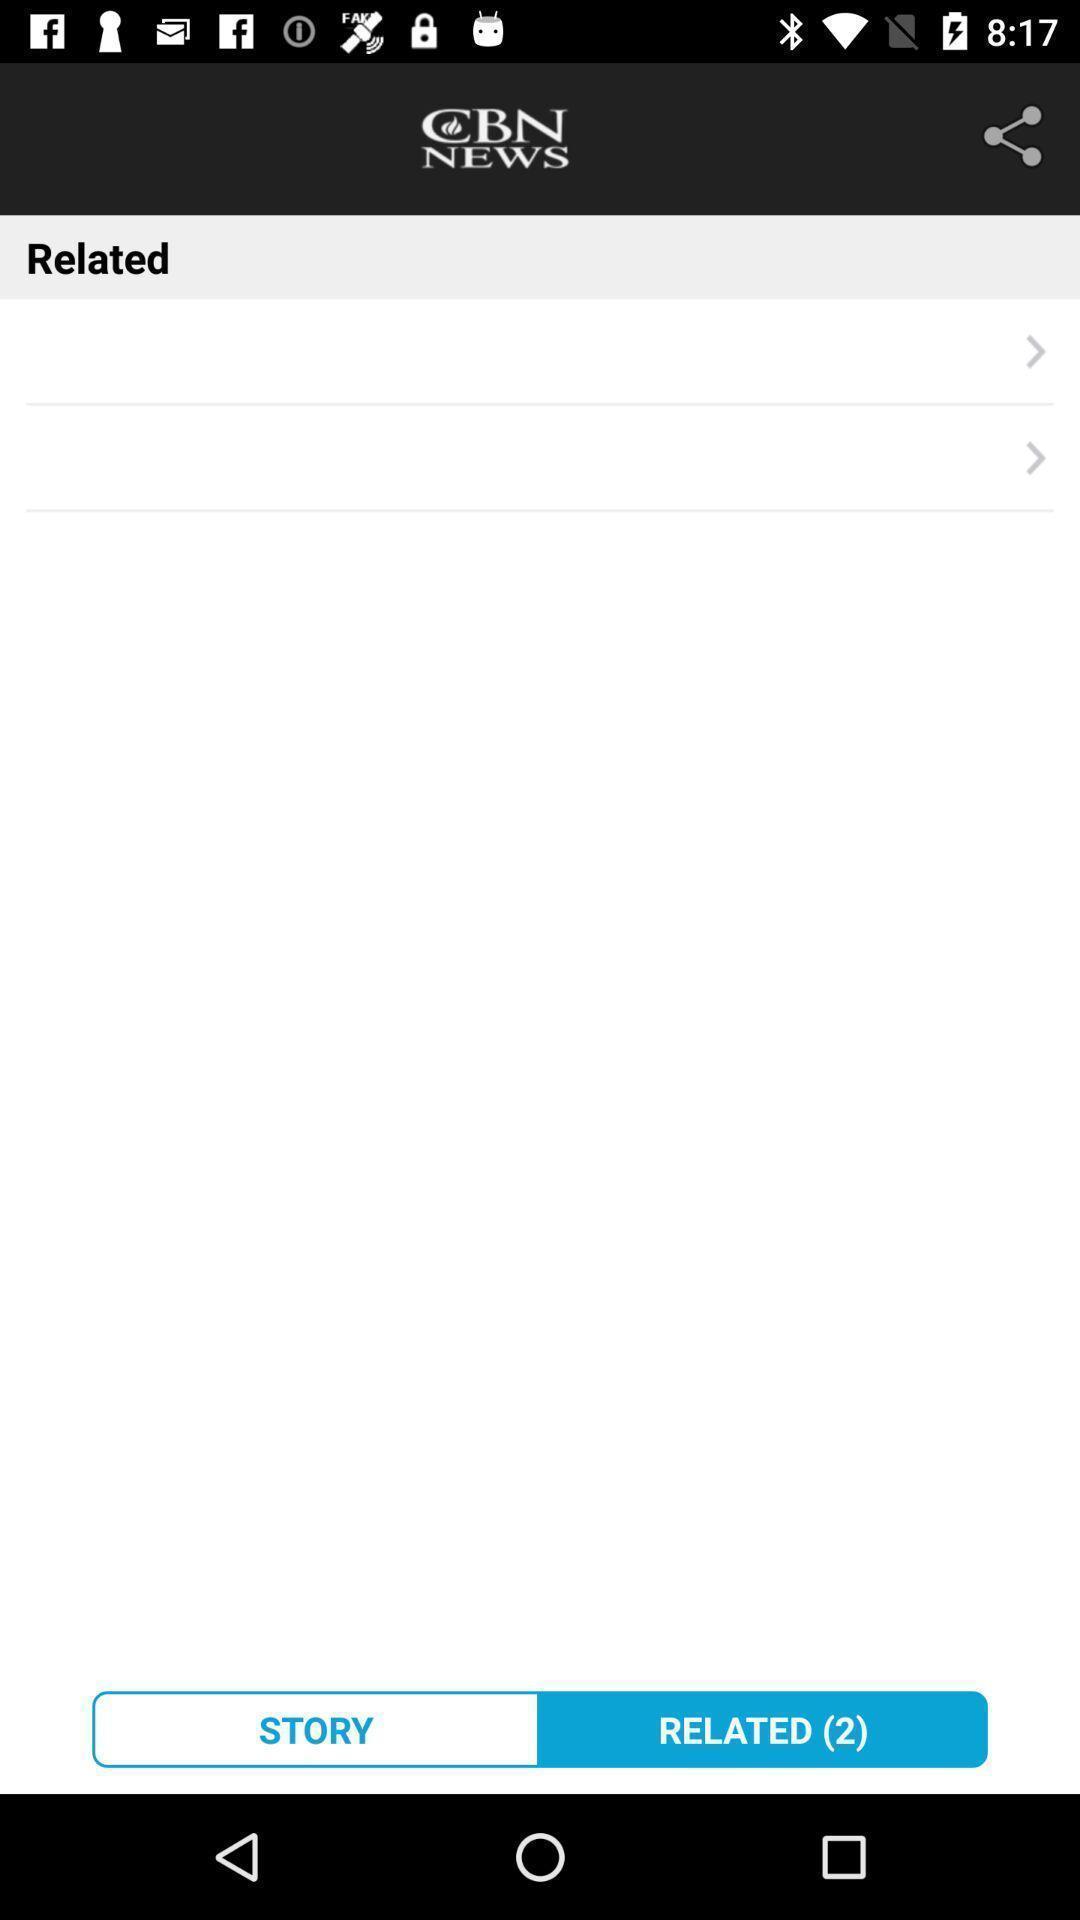Summarize the information in this screenshot. Screen shows related news in news app. 